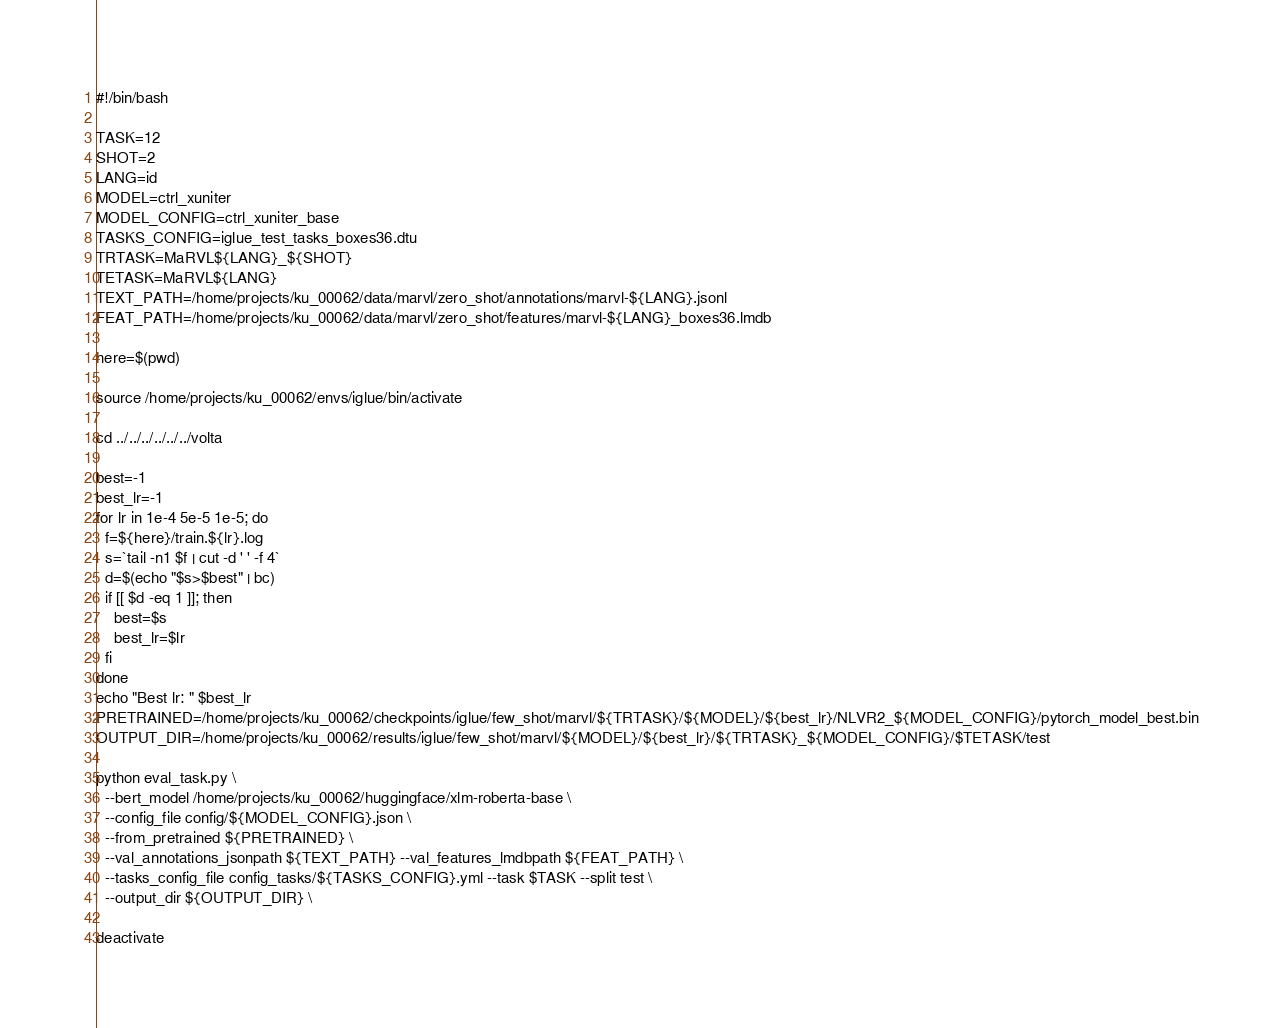<code> <loc_0><loc_0><loc_500><loc_500><_Bash_>#!/bin/bash

TASK=12
SHOT=2
LANG=id
MODEL=ctrl_xuniter
MODEL_CONFIG=ctrl_xuniter_base
TASKS_CONFIG=iglue_test_tasks_boxes36.dtu
TRTASK=MaRVL${LANG}_${SHOT}
TETASK=MaRVL${LANG}
TEXT_PATH=/home/projects/ku_00062/data/marvl/zero_shot/annotations/marvl-${LANG}.jsonl
FEAT_PATH=/home/projects/ku_00062/data/marvl/zero_shot/features/marvl-${LANG}_boxes36.lmdb

here=$(pwd)

source /home/projects/ku_00062/envs/iglue/bin/activate

cd ../../../../../../volta

best=-1
best_lr=-1
for lr in 1e-4 5e-5 1e-5; do
  f=${here}/train.${lr}.log
  s=`tail -n1 $f | cut -d ' ' -f 4`
  d=$(echo "$s>$best" | bc)
  if [[ $d -eq 1 ]]; then
    best=$s
    best_lr=$lr
  fi
done
echo "Best lr: " $best_lr
PRETRAINED=/home/projects/ku_00062/checkpoints/iglue/few_shot/marvl/${TRTASK}/${MODEL}/${best_lr}/NLVR2_${MODEL_CONFIG}/pytorch_model_best.bin
OUTPUT_DIR=/home/projects/ku_00062/results/iglue/few_shot/marvl/${MODEL}/${best_lr}/${TRTASK}_${MODEL_CONFIG}/$TETASK/test

python eval_task.py \
  --bert_model /home/projects/ku_00062/huggingface/xlm-roberta-base \
  --config_file config/${MODEL_CONFIG}.json \
  --from_pretrained ${PRETRAINED} \
  --val_annotations_jsonpath ${TEXT_PATH} --val_features_lmdbpath ${FEAT_PATH} \
  --tasks_config_file config_tasks/${TASKS_CONFIG}.yml --task $TASK --split test \
  --output_dir ${OUTPUT_DIR} \

deactivate
</code> 